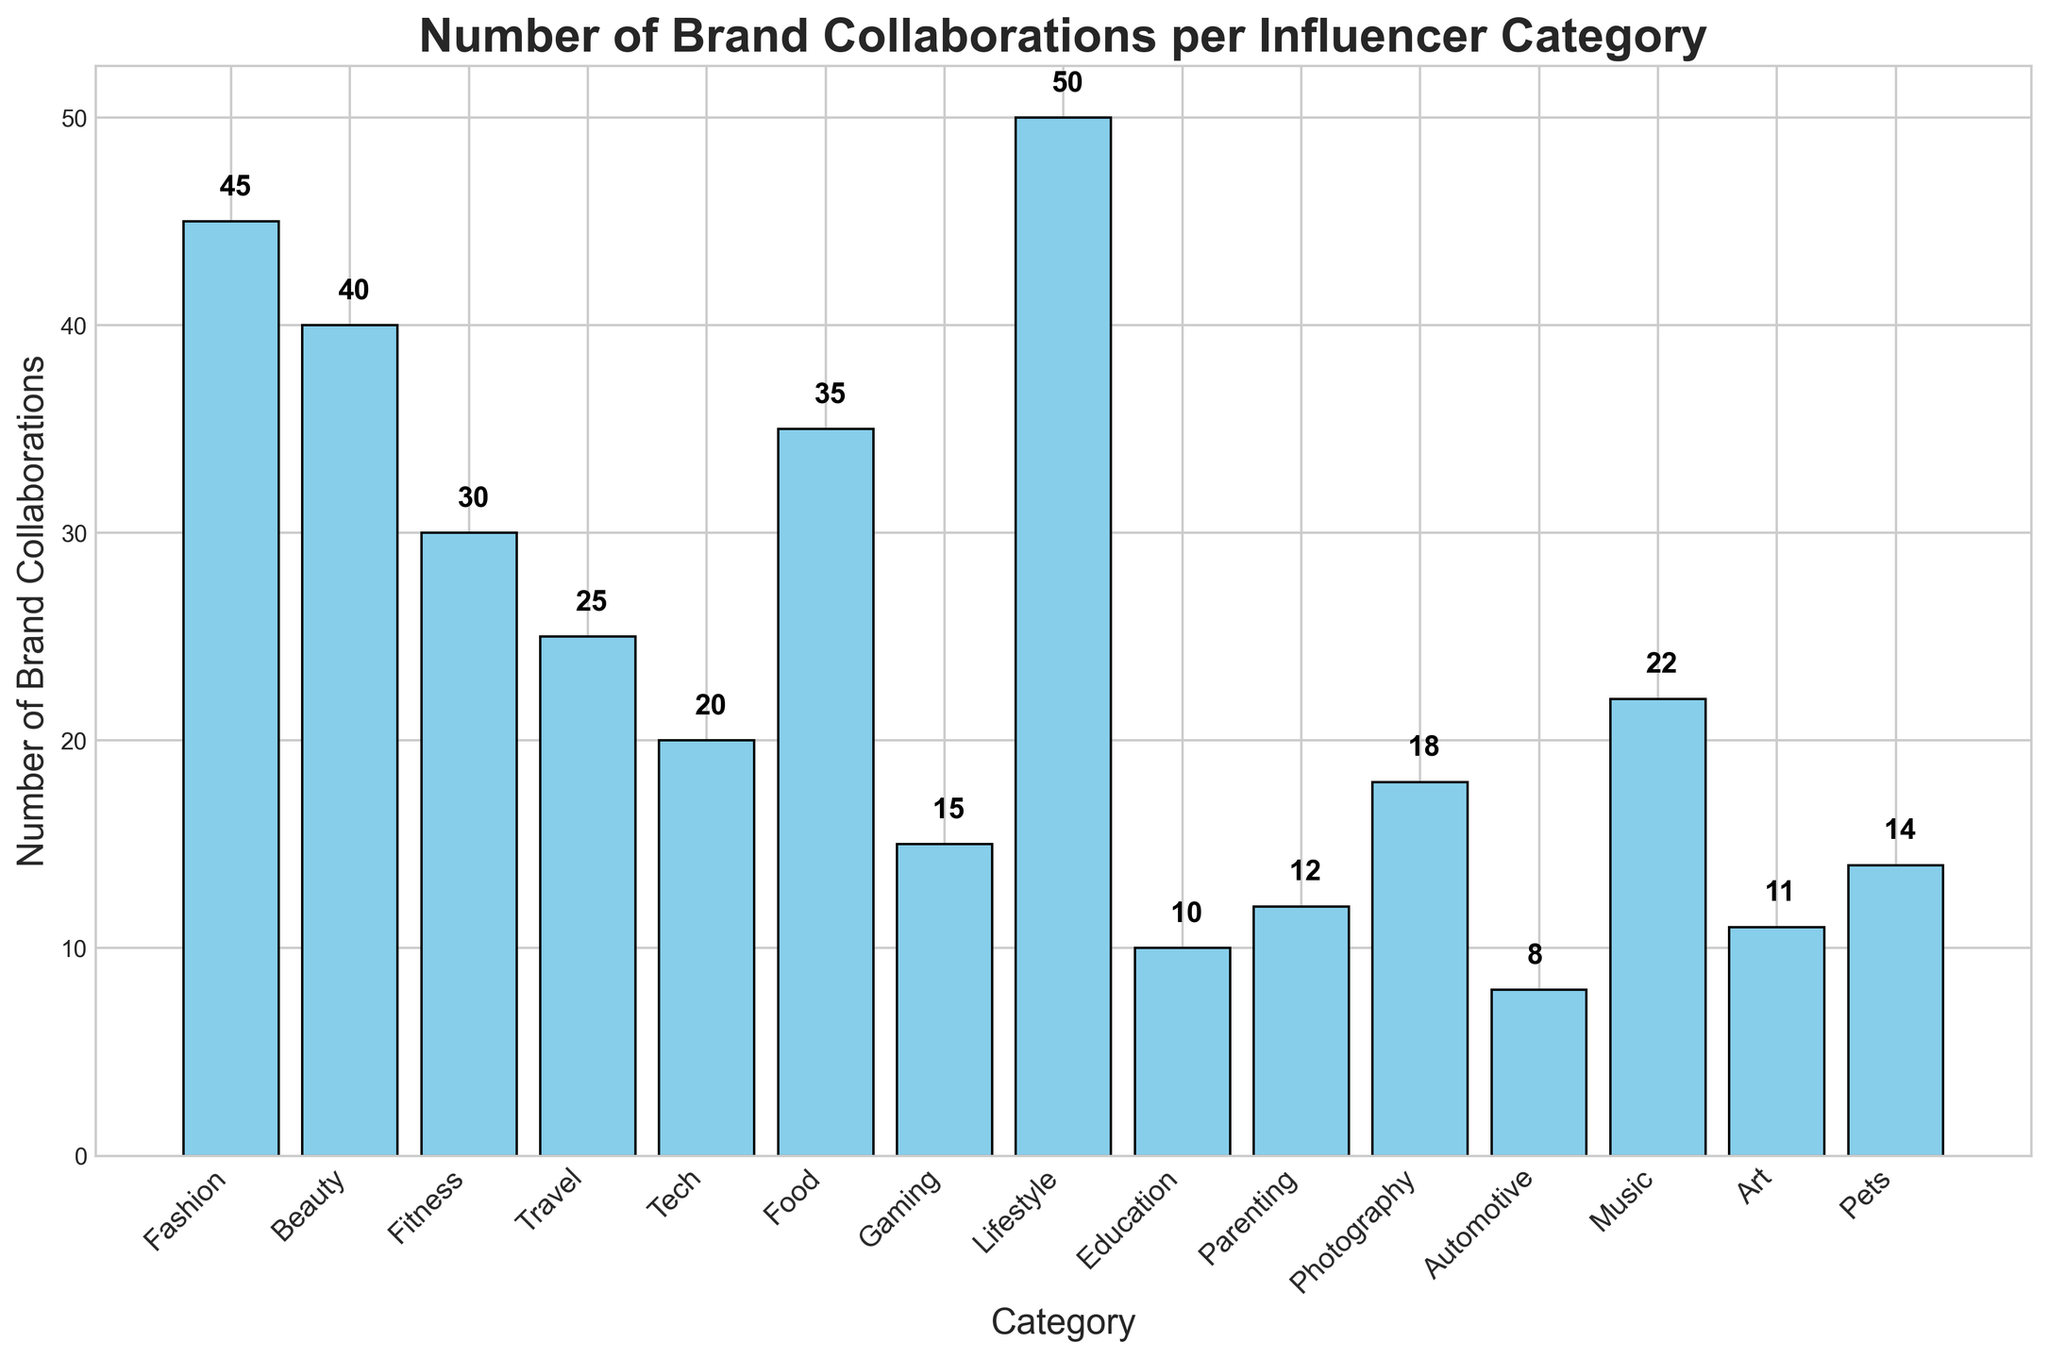What category has the highest number of brand collaborations? The bar corresponding to 'Lifestyle' reaches the highest point on the y-axis. Counting the number displayed above the bar confirms 50 collaborations.
Answer: Lifestyle Which category ranks second in terms of brand collaborations? Observing the bar heights, 'Fashion' stands next to 'Lifestyle' and reaches 45 collaborations, as marked.
Answer: Fashion What is the total number of brand collaborations for Fashion, Beauty, and Fitness combined? Adding the numbers from the bars for 'Fashion' (45), 'Beauty' (40), and 'Fitness' (30) yields 115
Answer: 115 How many more collaborations does the Fashion category have compared to the Automotive category? The 'Fashion' bar showed 45 collaborations whereas the 'Automotive' bar shows 8. Subtracting 8 from 45 gives 37.
Answer: 37 Which categories have fewer than 15 brand collaborations? The bars for 'Automotive', 'Education', 'Art', and 'Parenting' don't reach the 15 collaboration mark and had values 8, 10, 11, and 12 respectively.
Answer: Automotive, Education, Art, Parenting What is the average number of brand collaborations across all categories? Sum up the total number of collaborations in each category (45 + 40 + 30 + 25 + 20 + 35 + 15 + 50 + 10 + 12 + 18 + 8 + 22 + 11 + 14), which totals 355. Dividing by the number of categories (15) gets us 355/15 which is approximately 23.67.
Answer: 23.67 Which category has more collaborations: Travel or Tech? The bar for 'Travel' is higher at 25 collaborations compared to 'Tech' with 20 collaborations.
Answer: Travel How do the collaborations for Photography compare to Music? The bar for 'Music' at 22 is taller than 'Photography' at 18, so Music has more collaborations.
Answer: Music By how much does the number of collaborations for Food exceed that of Pets? 'Food' has 35 collaborations, 'Pets' has 14. Subtracting 14 from 35 gives a result of 21.
Answer: 21 Which categories have equal or nearly equal brand collaborations? The bars for 'Art' (11) and 'Parenting' (12) are almost equal in height, indicating nearly the same number of brand collaborations.
Answer: Art, Parenting 